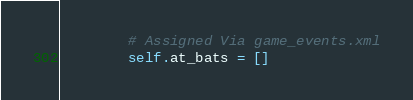<code> <loc_0><loc_0><loc_500><loc_500><_Python_>
        # Assigned Via game_events.xml
        self.at_bats = []

</code> 